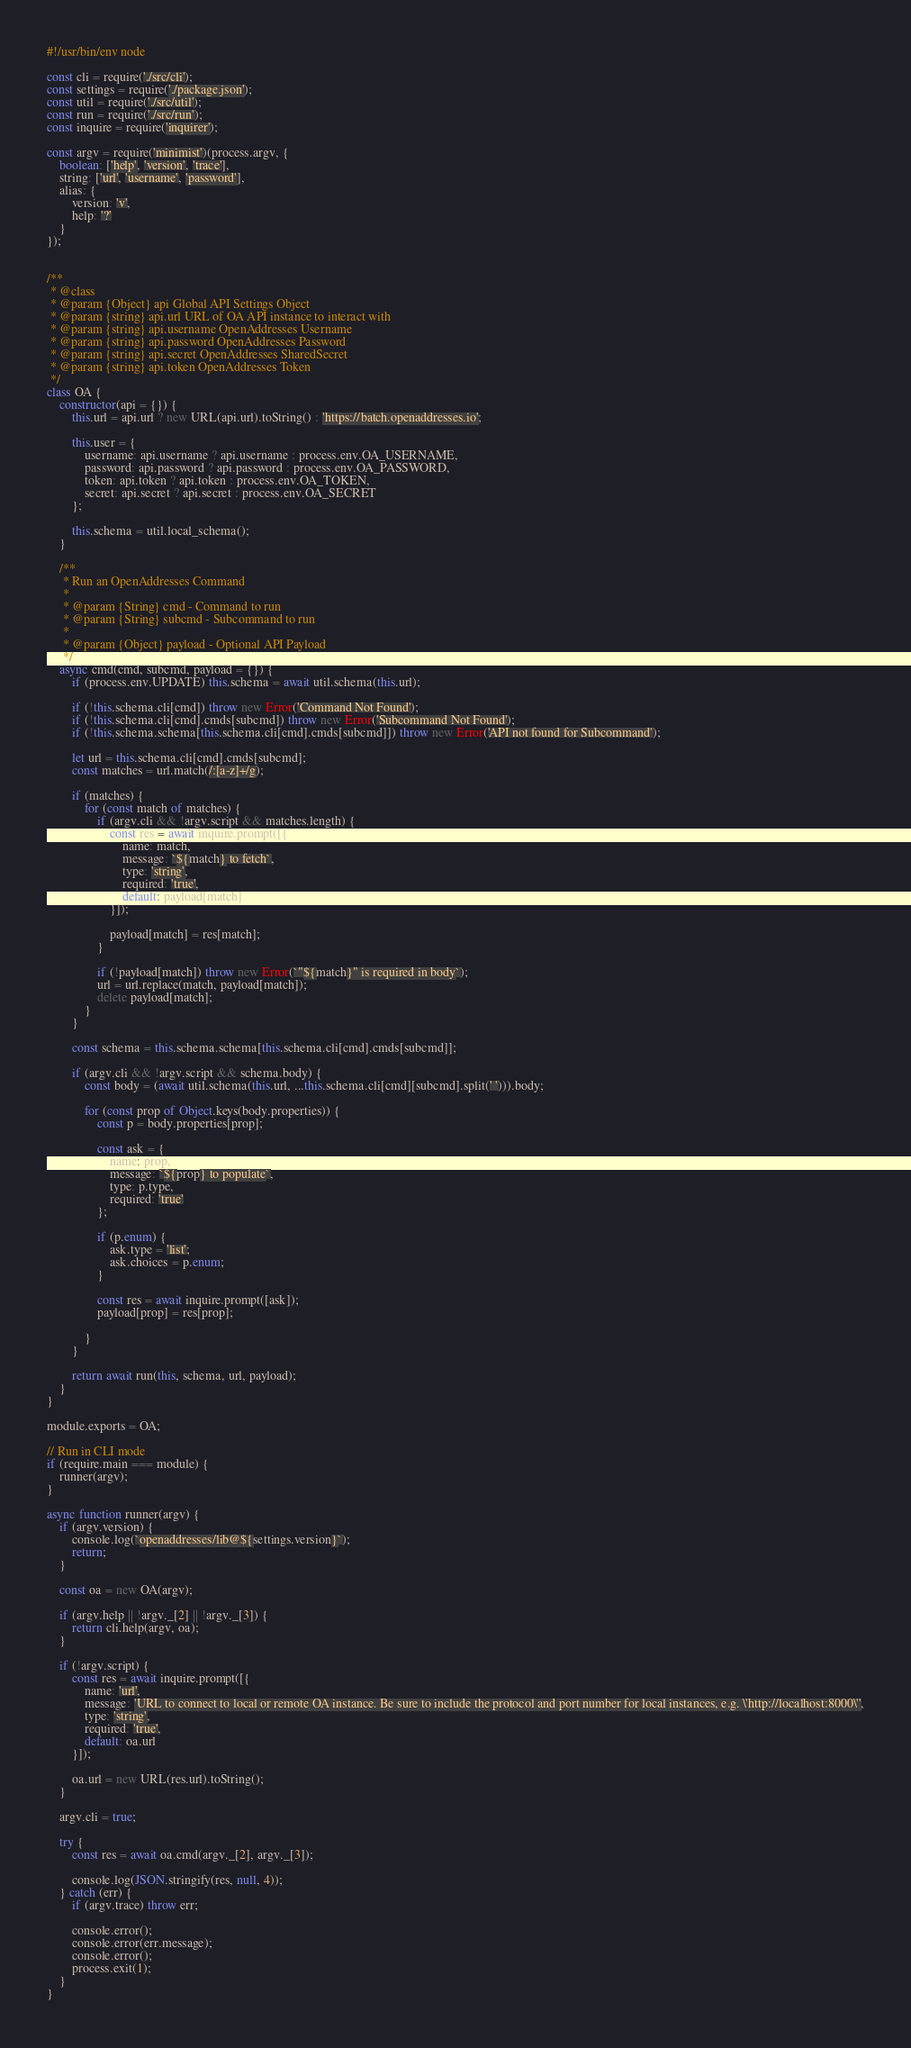<code> <loc_0><loc_0><loc_500><loc_500><_JavaScript_>#!/usr/bin/env node

const cli = require('./src/cli');
const settings = require('./package.json');
const util = require('./src/util');
const run = require('./src/run');
const inquire = require('inquirer');

const argv = require('minimist')(process.argv, {
    boolean: ['help', 'version', 'trace'],
    string: ['url', 'username', 'password'],
    alias: {
        version: 'v',
        help: '?'
    }
});


/**
 * @class
 * @param {Object} api Global API Settings Object
 * @param {string} api.url URL of OA API instance to interact with
 * @param {string} api.username OpenAddresses Username
 * @param {string} api.password OpenAddresses Password
 * @param {string} api.secret OpenAddresses SharedSecret
 * @param {string} api.token OpenAddresses Token
 */
class OA {
    constructor(api = {}) {
        this.url = api.url ? new URL(api.url).toString() : 'https://batch.openaddresses.io';

        this.user = {
            username: api.username ? api.username : process.env.OA_USERNAME,
            password: api.password ? api.password : process.env.OA_PASSWORD,
            token: api.token ? api.token : process.env.OA_TOKEN,
            secret: api.secret ? api.secret : process.env.OA_SECRET
        };

        this.schema = util.local_schema();
    }

    /**
     * Run an OpenAddresses Command
     *
     * @param {String} cmd - Command to run
     * @param {String} subcmd - Subcommand to run
     *
     * @param {Object} payload - Optional API Payload
     */
    async cmd(cmd, subcmd, payload = {}) {
        if (process.env.UPDATE) this.schema = await util.schema(this.url);

        if (!this.schema.cli[cmd]) throw new Error('Command Not Found');
        if (!this.schema.cli[cmd].cmds[subcmd]) throw new Error('Subcommand Not Found');
        if (!this.schema.schema[this.schema.cli[cmd].cmds[subcmd]]) throw new Error('API not found for Subcommand');

        let url = this.schema.cli[cmd].cmds[subcmd];
        const matches = url.match(/:[a-z]+/g);

        if (matches) {
            for (const match of matches) {
                if (argv.cli && !argv.script && matches.length) {
                    const res = await inquire.prompt([{
                        name: match,
                        message: `${match} to fetch`,
                        type: 'string',
                        required: 'true',
                        default: payload[match]
                    }]);

                    payload[match] = res[match];
                }

                if (!payload[match]) throw new Error(`"${match}" is required in body`);
                url = url.replace(match, payload[match]);
                delete payload[match];
            }
        }

        const schema = this.schema.schema[this.schema.cli[cmd].cmds[subcmd]];

        if (argv.cli && !argv.script && schema.body) {
            const body = (await util.schema(this.url, ...this.schema.cli[cmd][subcmd].split(' '))).body;

            for (const prop of Object.keys(body.properties)) {
                const p = body.properties[prop];

                const ask = {
                    name: prop,
                    message: `${prop} to populate`,
                    type: p.type,
                    required: 'true'
                };

                if (p.enum) {
                    ask.type = 'list';
                    ask.choices = p.enum;
                }

                const res = await inquire.prompt([ask]);
                payload[prop] = res[prop];

            }
        }

        return await run(this, schema, url, payload);
    }
}

module.exports = OA;

// Run in CLI mode
if (require.main === module) {
    runner(argv);
}

async function runner(argv) {
    if (argv.version) {
        console.log(`openaddresses/lib@${settings.version}`);
        return;
    }

    const oa = new OA(argv);

    if (argv.help || !argv._[2] || !argv._[3]) {
        return cli.help(argv, oa);
    }

    if (!argv.script) {
        const res = await inquire.prompt([{
            name: 'url',
            message: 'URL to connect to local or remote OA instance. Be sure to include the protocol and port number for local instances, e.g. \'http://localhost:8000\'',
            type: 'string',
            required: 'true',
            default: oa.url
        }]);

        oa.url = new URL(res.url).toString();
    }

    argv.cli = true;

    try {
        const res = await oa.cmd(argv._[2], argv._[3]);

        console.log(JSON.stringify(res, null, 4));
    } catch (err) {
        if (argv.trace) throw err;

        console.error();
        console.error(err.message);
        console.error();
        process.exit(1);
    }
}
</code> 